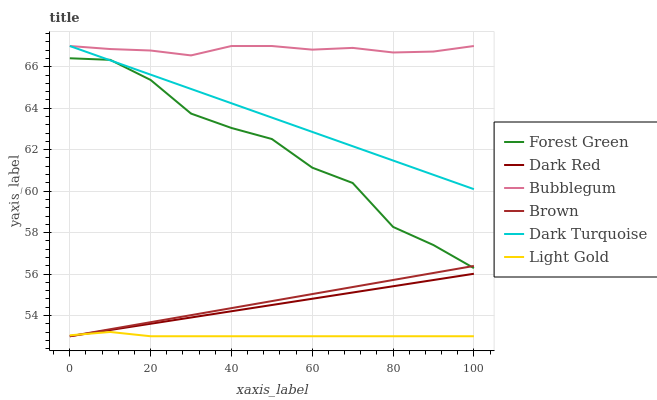Does Dark Red have the minimum area under the curve?
Answer yes or no. No. Does Dark Red have the maximum area under the curve?
Answer yes or no. No. Is Dark Red the smoothest?
Answer yes or no. No. Is Dark Red the roughest?
Answer yes or no. No. Does Bubblegum have the lowest value?
Answer yes or no. No. Does Dark Red have the highest value?
Answer yes or no. No. Is Light Gold less than Dark Turquoise?
Answer yes or no. Yes. Is Forest Green greater than Dark Red?
Answer yes or no. Yes. Does Light Gold intersect Dark Turquoise?
Answer yes or no. No. 